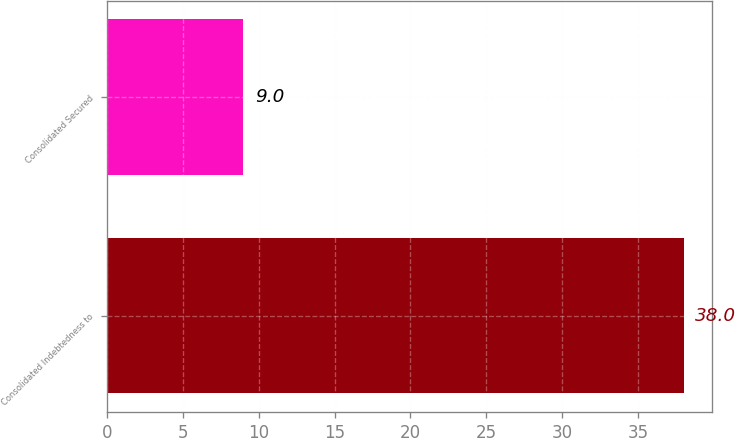<chart> <loc_0><loc_0><loc_500><loc_500><bar_chart><fcel>Consolidated Indebtedness to<fcel>Consolidated Secured<nl><fcel>38<fcel>9<nl></chart> 